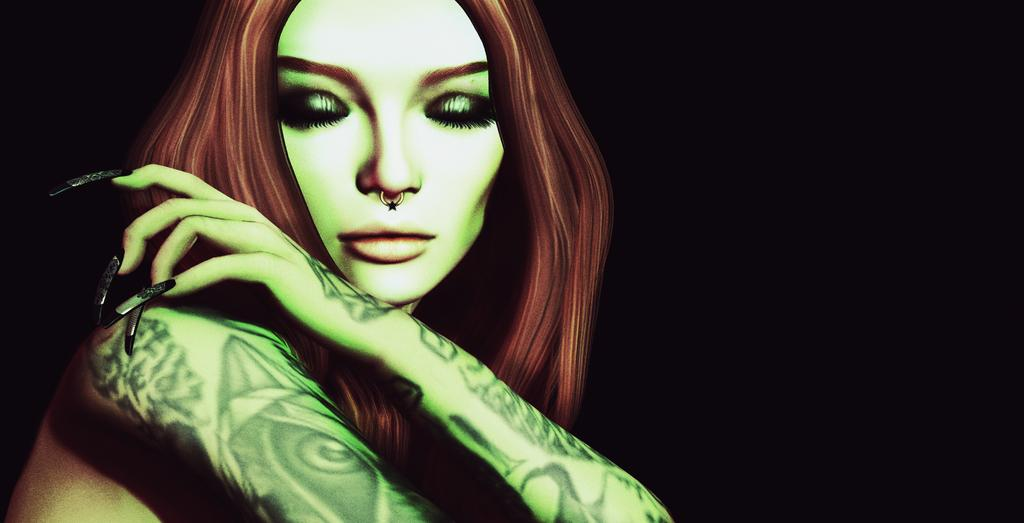What type of image is being shown? The image is an editing picture. Can you describe the main subject of the image? There is a woman in the center of the image. What type of furniture is present in the image? There is no furniture present in the image; it only features a woman in the center. How does the society depicted in the image function? The image does not depict a society, so it is not possible to determine how it functions. 